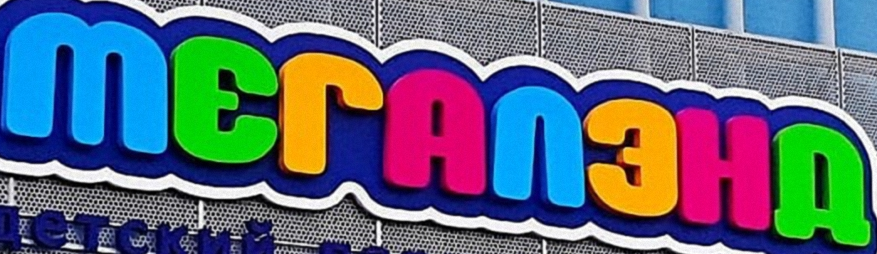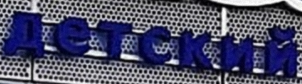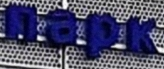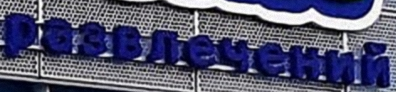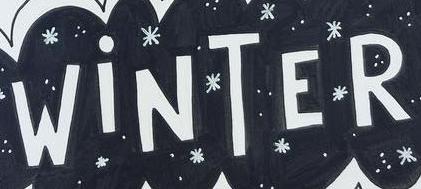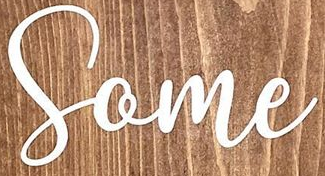What text is displayed in these images sequentially, separated by a semicolon? MЕГAΛЗHД; детский; пapk; paзвлeчeний; WiNTER; Some 